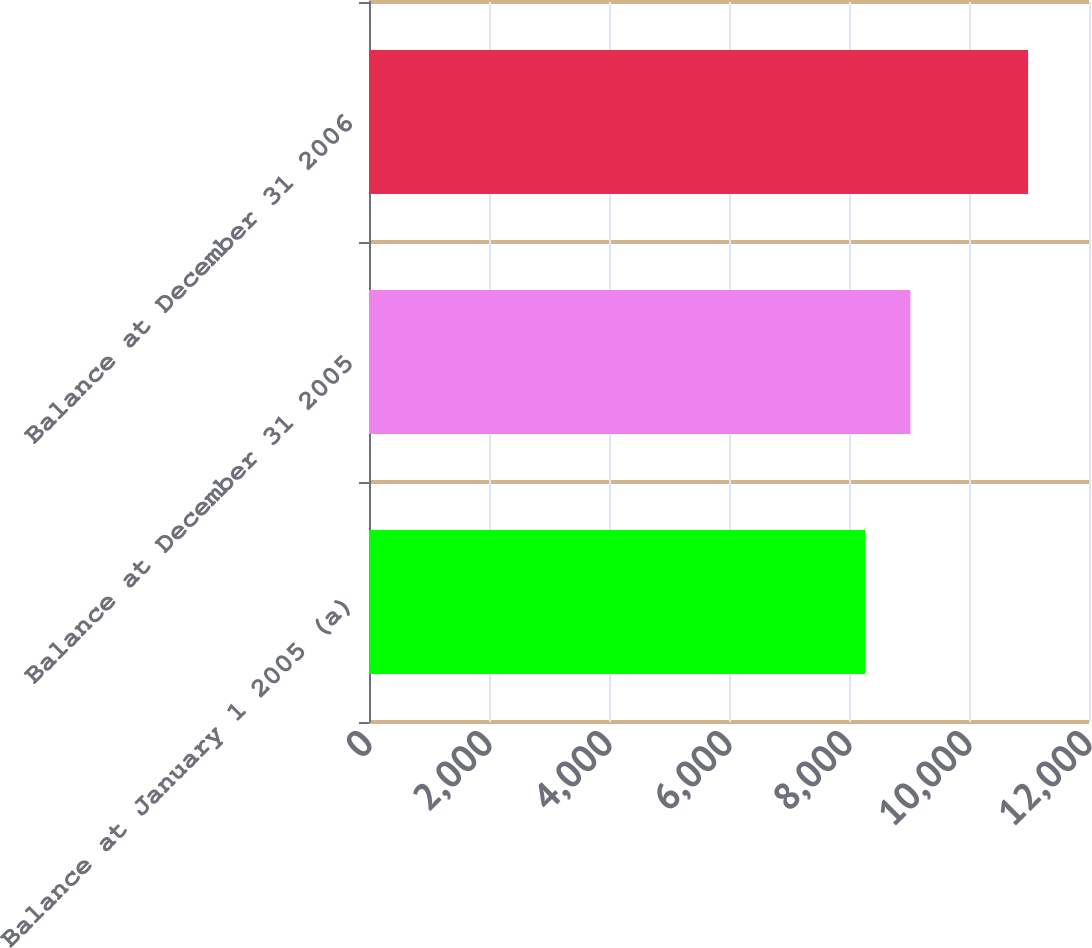Convert chart to OTSL. <chart><loc_0><loc_0><loc_500><loc_500><bar_chart><fcel>Balance at January 1 2005 (a)<fcel>Balance at December 31 2005<fcel>Balance at December 31 2006<nl><fcel>8273<fcel>9023<fcel>10985<nl></chart> 